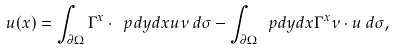<formula> <loc_0><loc_0><loc_500><loc_500>u ( x ) = \int _ { \partial \Omega } \Gamma ^ { x } \cdot \ p d y d x { u } { \nu } \, d \sigma - \int _ { \partial \Omega } \ p d y d x { \Gamma ^ { x } } { \nu } \cdot u \, d \sigma ,</formula> 